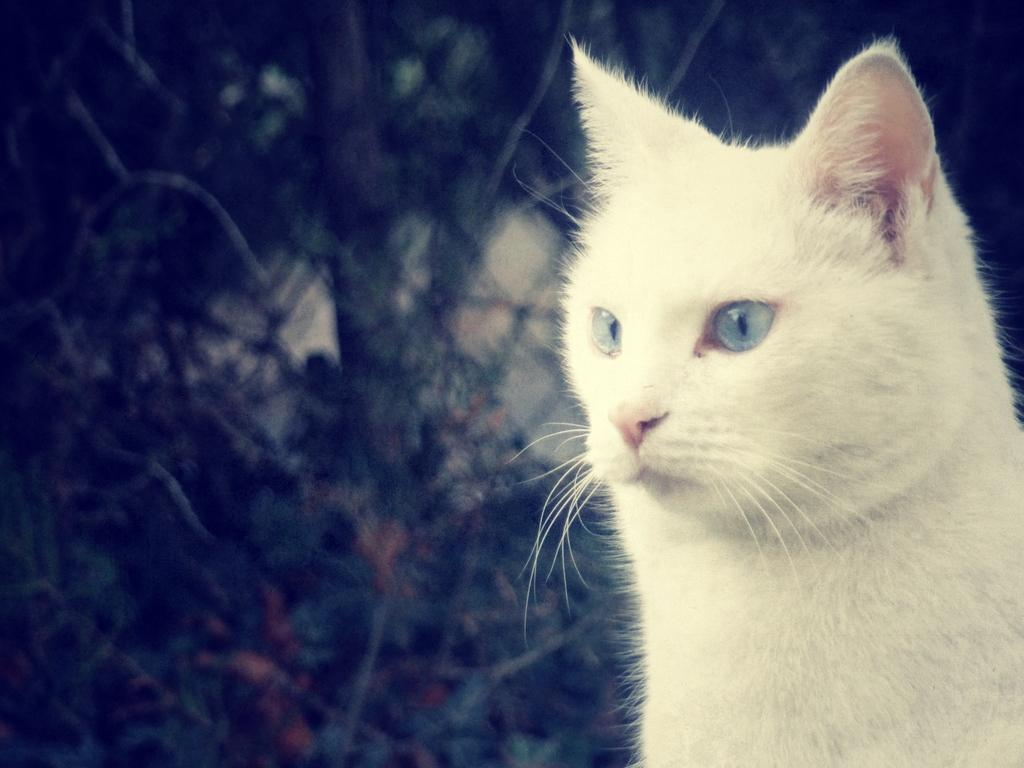What type of animal is in the picture? There is a cat in the picture. What color is the cat? The cat is white in color. Can you describe the objects behind the cat? The visibility of the objects behind the cat is unclear, so it's difficult to describe them. Is the cat playing with a part of the smoke in the image? There is no smoke present in the image, and the cat is not shown playing with any objects. 